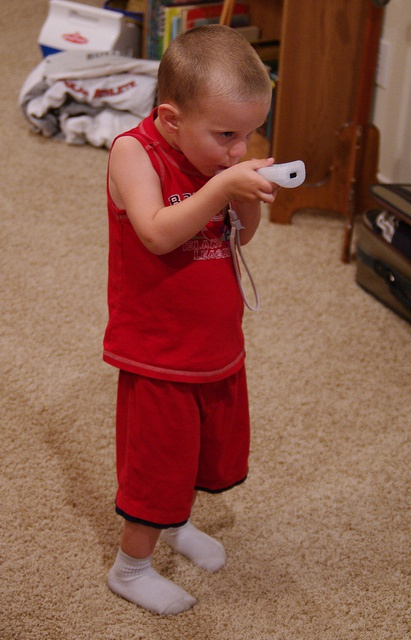Describe the objects in this image and their specific colors. I can see people in gray, maroon, and brown tones, remote in gray, darkgray, and black tones, book in gray and olive tones, book in gray, maroon, and brown tones, and book in gray and black tones in this image. 